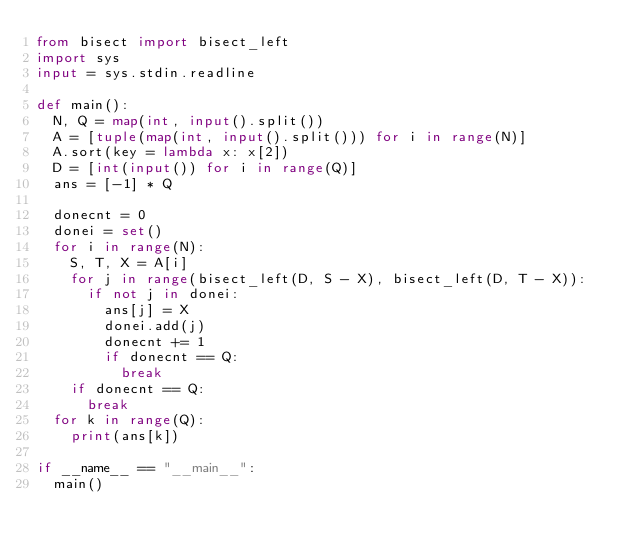Convert code to text. <code><loc_0><loc_0><loc_500><loc_500><_Python_>from bisect import bisect_left
import sys
input = sys.stdin.readline

def main():
	N, Q = map(int, input().split())
	A = [tuple(map(int, input().split())) for i in range(N)]
	A.sort(key = lambda x: x[2])
	D = [int(input()) for i in range(Q)]
	ans = [-1] * Q
	
	donecnt = 0
	donei = set()
	for i in range(N):
		S, T, X = A[i]
		for j in range(bisect_left(D, S - X), bisect_left(D, T - X)):
			if not j in donei:
				ans[j] = X
				donei.add(j)
				donecnt += 1
				if donecnt == Q:
					break
		if donecnt == Q:
			break
	for k in range(Q):
		print(ans[k])
		
if __name__ == "__main__":
	main()</code> 